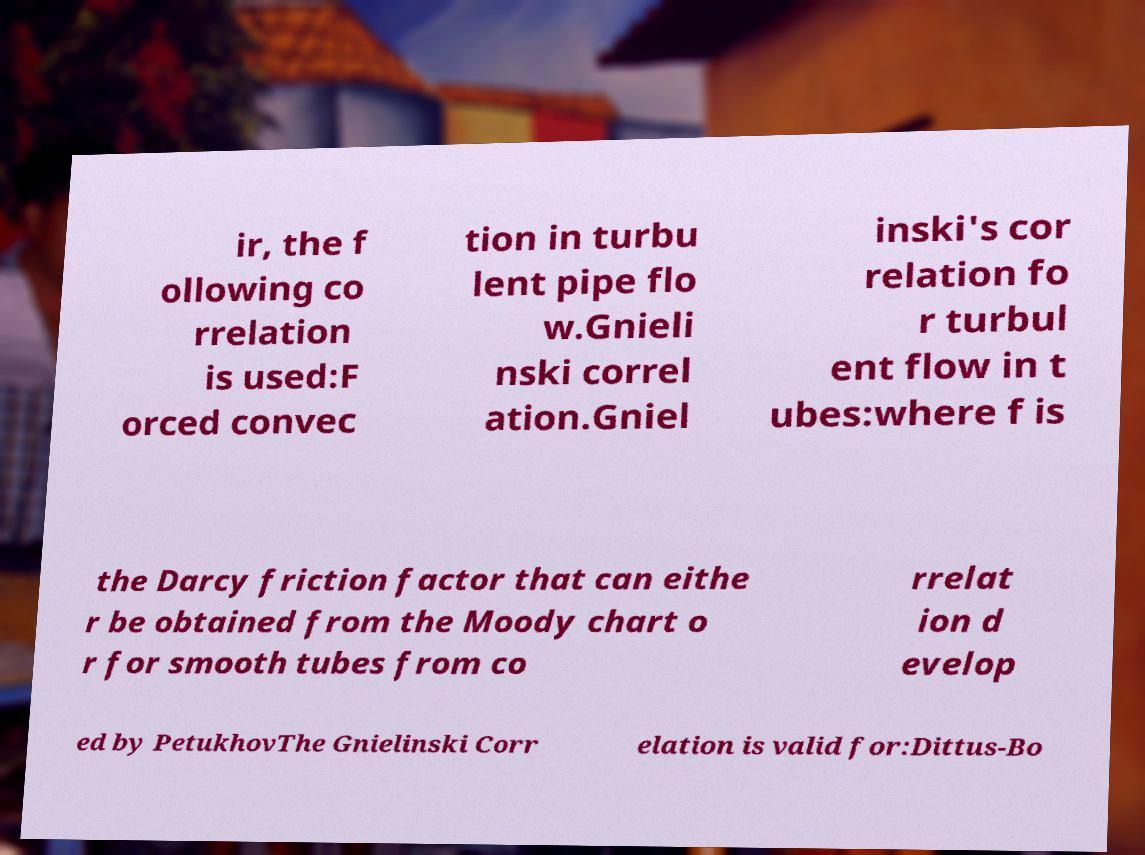For documentation purposes, I need the text within this image transcribed. Could you provide that? ir, the f ollowing co rrelation is used:F orced convec tion in turbu lent pipe flo w.Gnieli nski correl ation.Gniel inski's cor relation fo r turbul ent flow in t ubes:where f is the Darcy friction factor that can eithe r be obtained from the Moody chart o r for smooth tubes from co rrelat ion d evelop ed by PetukhovThe Gnielinski Corr elation is valid for:Dittus-Bo 